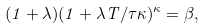<formula> <loc_0><loc_0><loc_500><loc_500>( 1 + \lambda ) ( 1 + \lambda T / \tau \kappa ) ^ { \kappa } = \beta ,</formula> 